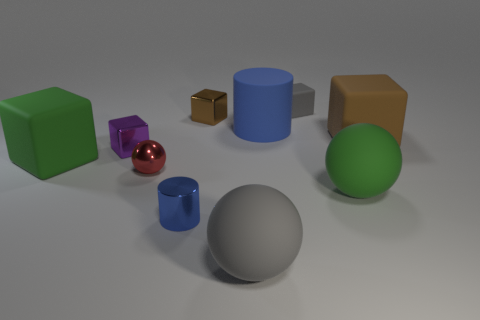How many other objects are there of the same color as the matte cylinder?
Offer a terse response. 1. The green rubber thing that is the same size as the green rubber block is what shape?
Keep it short and to the point. Sphere. There is a shiny block that is in front of the brown metal block; what color is it?
Ensure brevity in your answer.  Purple. How many objects are either large rubber things to the left of the small metal cylinder or things on the left side of the big blue cylinder?
Provide a short and direct response. 6. Does the gray matte cube have the same size as the brown rubber cube?
Ensure brevity in your answer.  No. What number of balls are either large blue metal objects or red shiny objects?
Provide a short and direct response. 1. What number of small things are on the right side of the small ball and behind the green matte ball?
Keep it short and to the point. 2. Is the size of the gray cube the same as the brown metal object that is in front of the gray matte block?
Offer a terse response. Yes. Is there a small cylinder that is behind the blue object that is behind the small metallic cube in front of the blue matte object?
Provide a short and direct response. No. What material is the gray thing that is behind the large green object left of the tiny gray rubber block?
Provide a succinct answer. Rubber. 